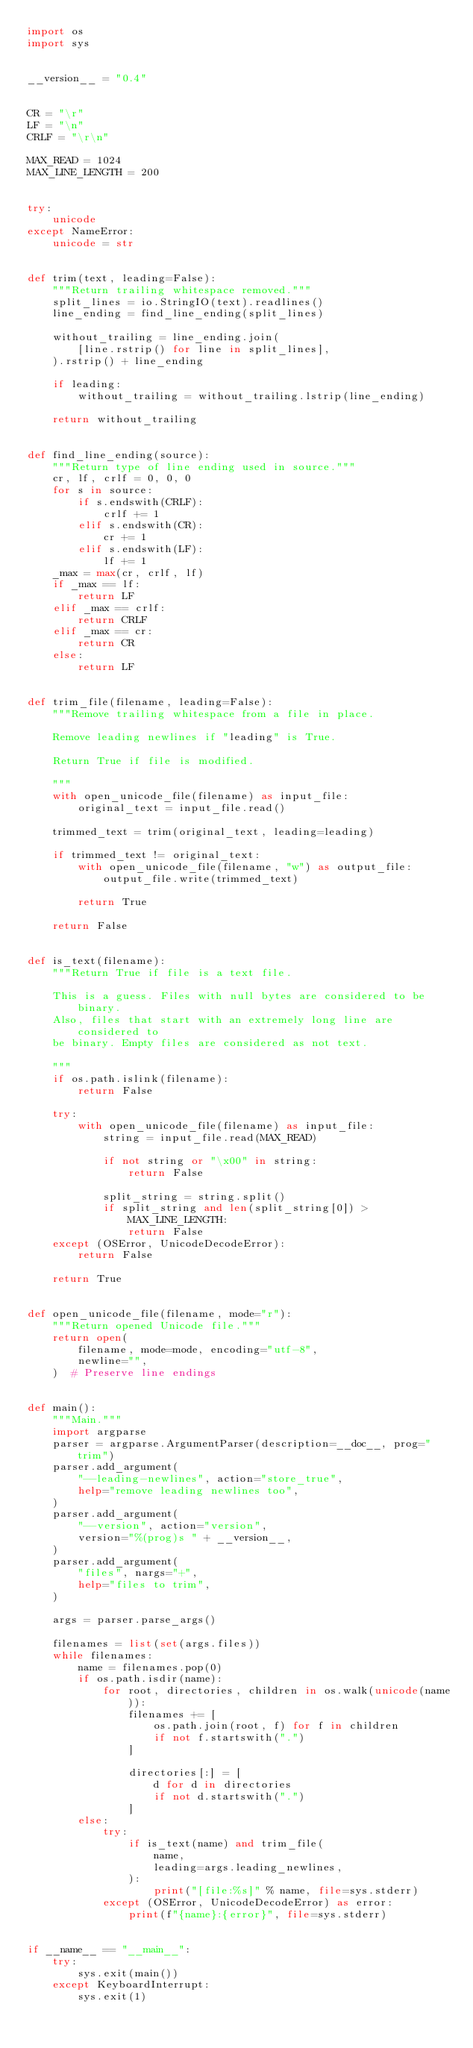Convert code to text. <code><loc_0><loc_0><loc_500><loc_500><_Python_>import os
import sys


__version__ = "0.4"


CR = "\r"
LF = "\n"
CRLF = "\r\n"

MAX_READ = 1024
MAX_LINE_LENGTH = 200


try:
    unicode
except NameError:
    unicode = str


def trim(text, leading=False):
    """Return trailing whitespace removed."""
    split_lines = io.StringIO(text).readlines()
    line_ending = find_line_ending(split_lines)

    without_trailing = line_ending.join(
        [line.rstrip() for line in split_lines],
    ).rstrip() + line_ending

    if leading:
        without_trailing = without_trailing.lstrip(line_ending)

    return without_trailing


def find_line_ending(source):
    """Return type of line ending used in source."""
    cr, lf, crlf = 0, 0, 0
    for s in source:
        if s.endswith(CRLF):
            crlf += 1
        elif s.endswith(CR):
            cr += 1
        elif s.endswith(LF):
            lf += 1
    _max = max(cr, crlf, lf)
    if _max == lf:
        return LF
    elif _max == crlf:
        return CRLF
    elif _max == cr:
        return CR
    else:
        return LF


def trim_file(filename, leading=False):
    """Remove trailing whitespace from a file in place.

    Remove leading newlines if "leading" is True.

    Return True if file is modified.

    """
    with open_unicode_file(filename) as input_file:
        original_text = input_file.read()

    trimmed_text = trim(original_text, leading=leading)

    if trimmed_text != original_text:
        with open_unicode_file(filename, "w") as output_file:
            output_file.write(trimmed_text)

        return True

    return False


def is_text(filename):
    """Return True if file is a text file.

    This is a guess. Files with null bytes are considered to be binary.
    Also, files that start with an extremely long line are considered to
    be binary. Empty files are considered as not text.

    """
    if os.path.islink(filename):
        return False

    try:
        with open_unicode_file(filename) as input_file:
            string = input_file.read(MAX_READ)

            if not string or "\x00" in string:
                return False

            split_string = string.split()
            if split_string and len(split_string[0]) > MAX_LINE_LENGTH:
                return False
    except (OSError, UnicodeDecodeError):
        return False

    return True


def open_unicode_file(filename, mode="r"):
    """Return opened Unicode file."""
    return open(
        filename, mode=mode, encoding="utf-8",
        newline="",
    )  # Preserve line endings


def main():
    """Main."""
    import argparse
    parser = argparse.ArgumentParser(description=__doc__, prog="trim")
    parser.add_argument(
        "--leading-newlines", action="store_true",
        help="remove leading newlines too",
    )
    parser.add_argument(
        "--version", action="version",
        version="%(prog)s " + __version__,
    )
    parser.add_argument(
        "files", nargs="+",
        help="files to trim",
    )

    args = parser.parse_args()

    filenames = list(set(args.files))
    while filenames:
        name = filenames.pop(0)
        if os.path.isdir(name):
            for root, directories, children in os.walk(unicode(name)):
                filenames += [
                    os.path.join(root, f) for f in children
                    if not f.startswith(".")
                ]

                directories[:] = [
                    d for d in directories
                    if not d.startswith(".")
                ]
        else:
            try:
                if is_text(name) and trim_file(
                    name,
                    leading=args.leading_newlines,
                ):
                    print("[file:%s]" % name, file=sys.stderr)
            except (OSError, UnicodeDecodeError) as error:
                print(f"{name}:{error}", file=sys.stderr)


if __name__ == "__main__":
    try:
        sys.exit(main())
    except KeyboardInterrupt:
        sys.exit(1)
</code> 